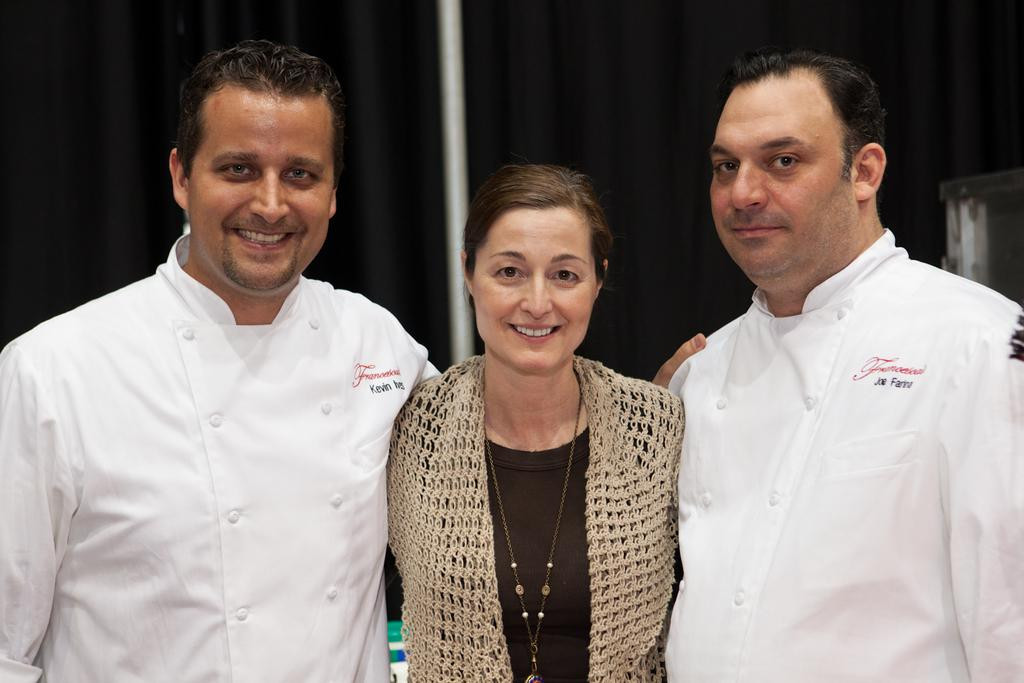How many people are in the image? There are two persons standing and smiling in the image. Can you describe the people in the image? There is a person standing in the image, and they are both standing and smiling. What can be seen in the background of the image? There is a curtain, a pole, and an object in the background of the image. What type of toys can be seen on the slope in the image? There is no slope or toys present in the image. What activity are the people engaged in while standing in the image? The provided facts do not mention any specific activity the people are engaged in; they are simply standing and smiling. 